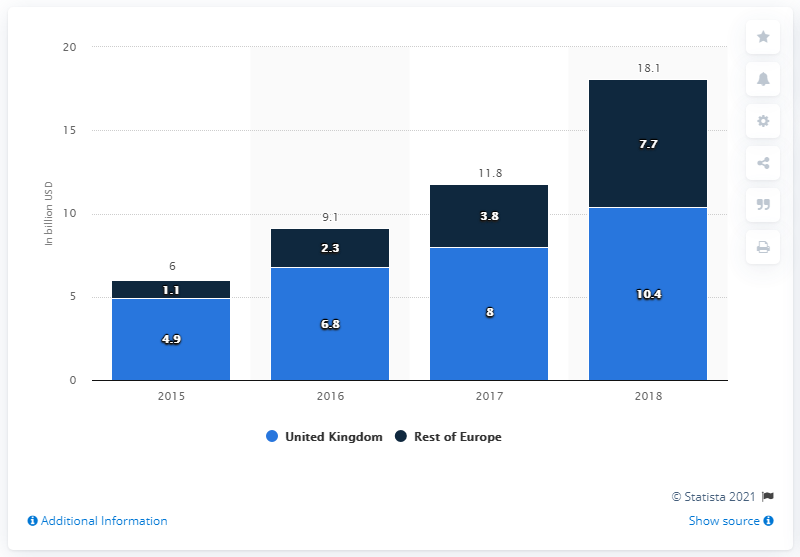Indicate a few pertinent items in this graphic. In 2018, the alternative finance market in the UK was valued at 10.4 billion pounds. In 2015, the alternative finance market in the rest of Europe had a value of 1.1 billion euros. In 2015, the value of the alternative finance market in the United States was 4.9 billion dollars. 